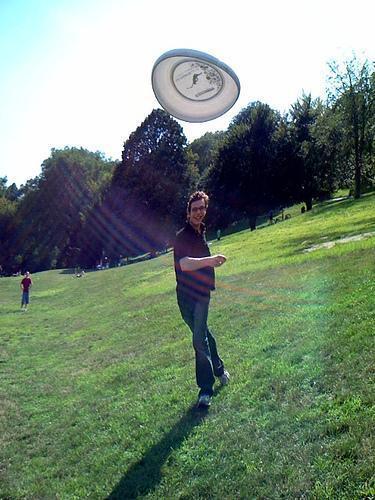How many beds in this image require a ladder to get into?
Give a very brief answer. 0. 